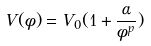<formula> <loc_0><loc_0><loc_500><loc_500>V ( \phi ) = V _ { 0 } ( 1 + \frac { \alpha } { \phi ^ { p } } )</formula> 